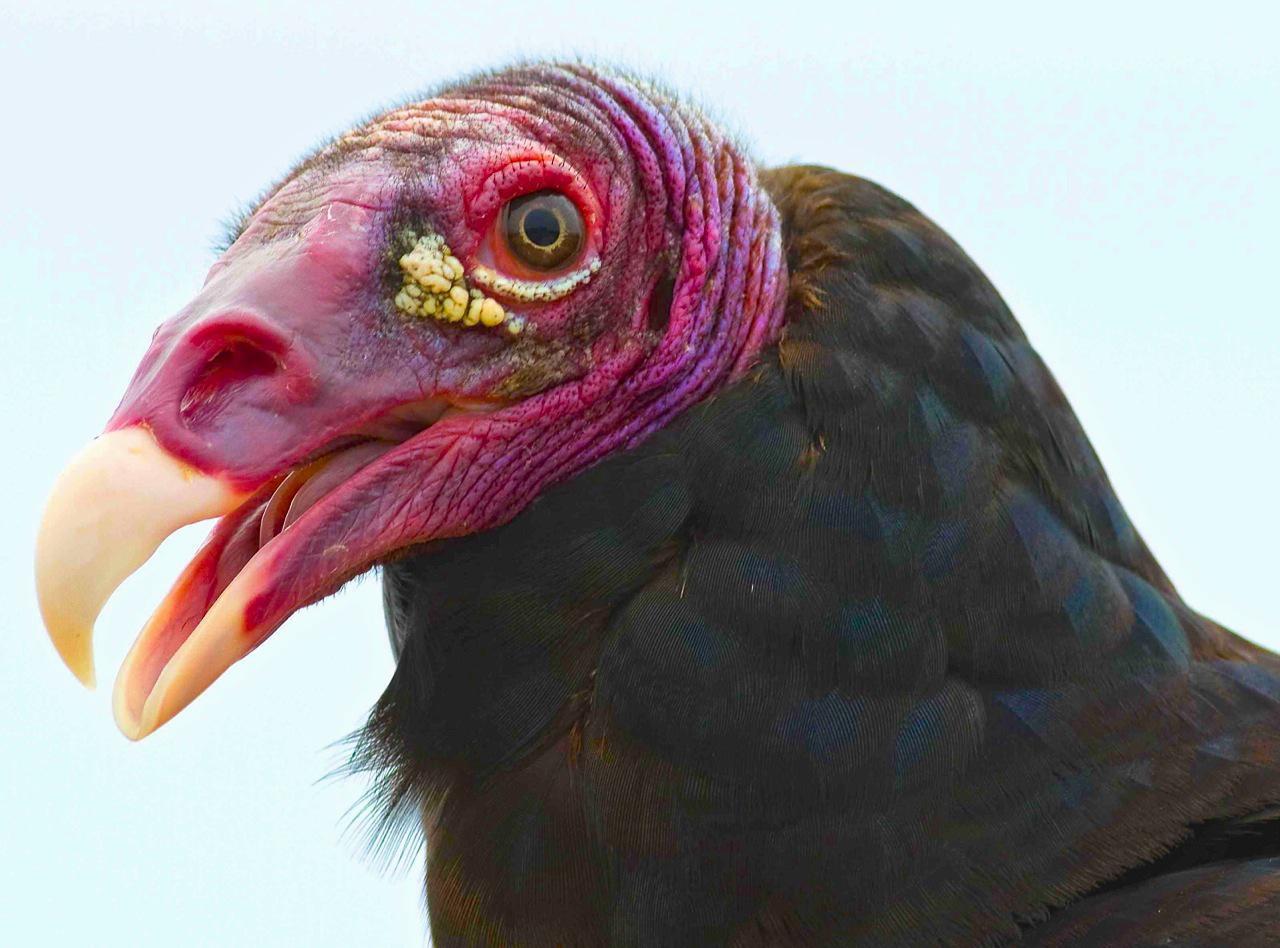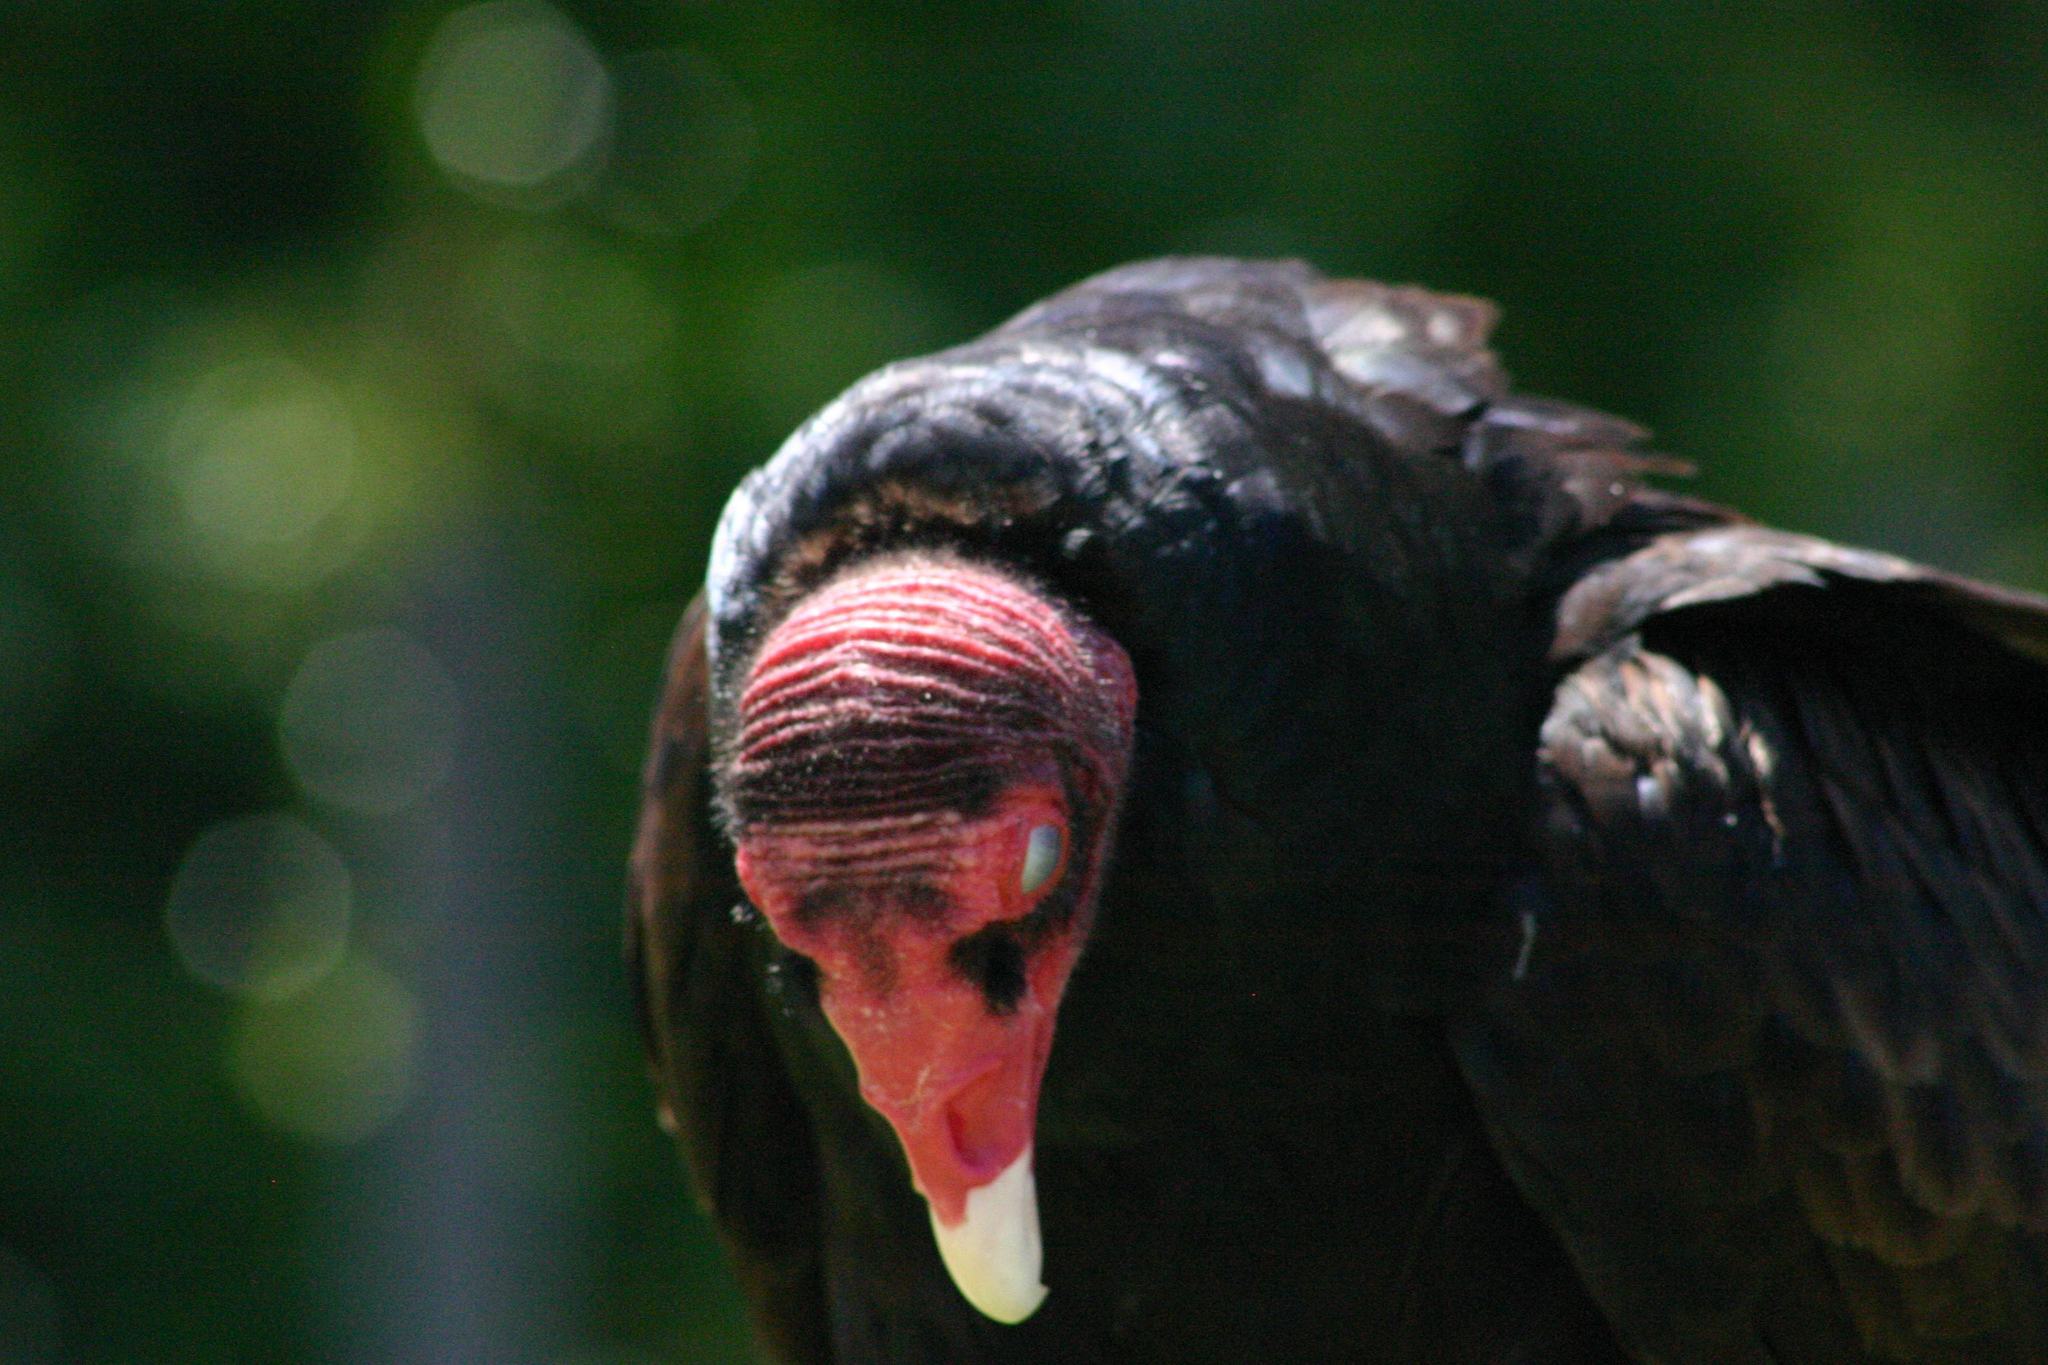The first image is the image on the left, the second image is the image on the right. Analyze the images presented: Is the assertion "Left and right images show heads of vultures facing opposite left-or-right directions." valid? Answer yes or no. No. The first image is the image on the left, the second image is the image on the right. For the images displayed, is the sentence "The bird in the left image is looking towards the left." factually correct? Answer yes or no. Yes. 